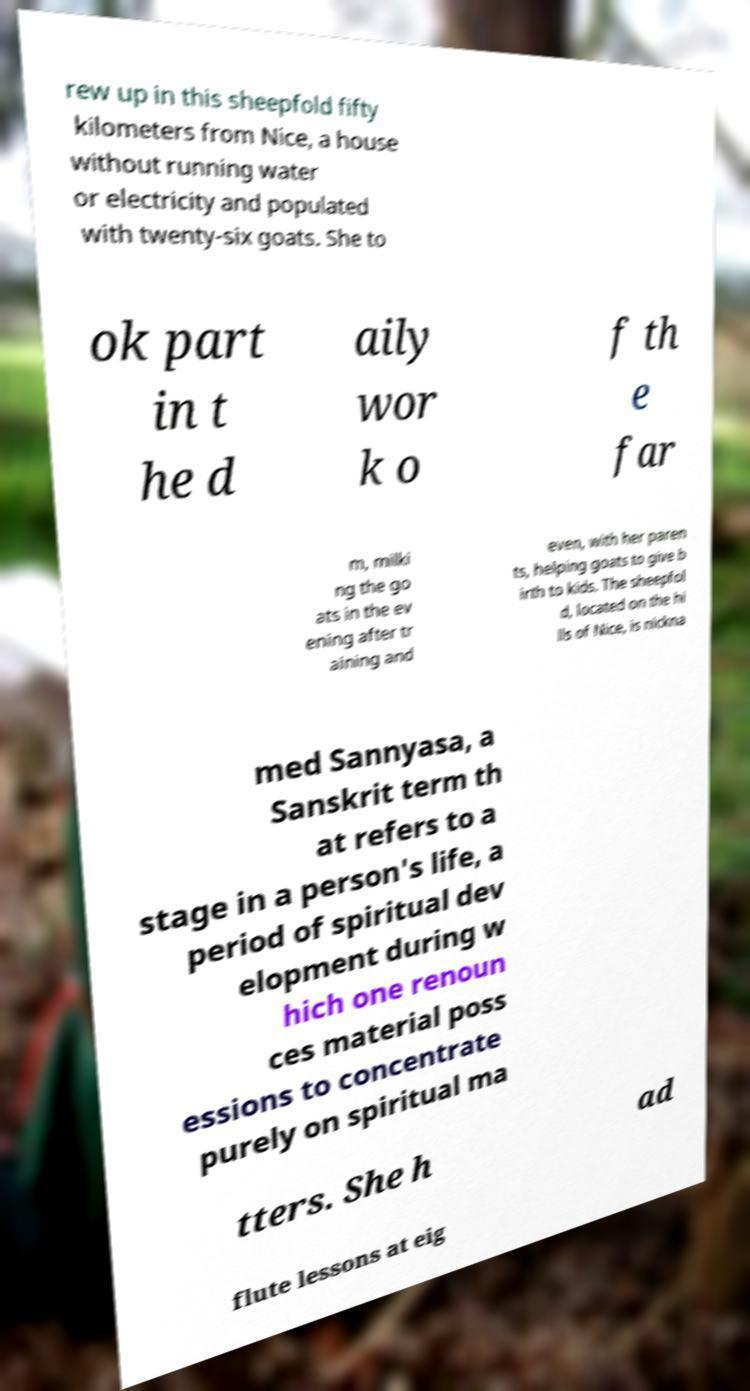Please identify and transcribe the text found in this image. rew up in this sheepfold fifty kilometers from Nice, a house without running water or electricity and populated with twenty-six goats. She to ok part in t he d aily wor k o f th e far m, milki ng the go ats in the ev ening after tr aining and even, with her paren ts, helping goats to give b irth to kids. The sheepfol d, located on the hi lls of Nice, is nickna med Sannyasa, a Sanskrit term th at refers to a stage in a person's life, a period of spiritual dev elopment during w hich one renoun ces material poss essions to concentrate purely on spiritual ma tters. She h ad flute lessons at eig 